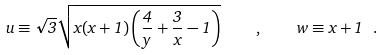<formula> <loc_0><loc_0><loc_500><loc_500>u \equiv \sqrt { 3 } \sqrt { x ( x + 1 ) \left ( \frac { 4 } { y } + \frac { 3 } { x } - 1 \right ) } \quad , \quad w \equiv x + 1 \ .</formula> 